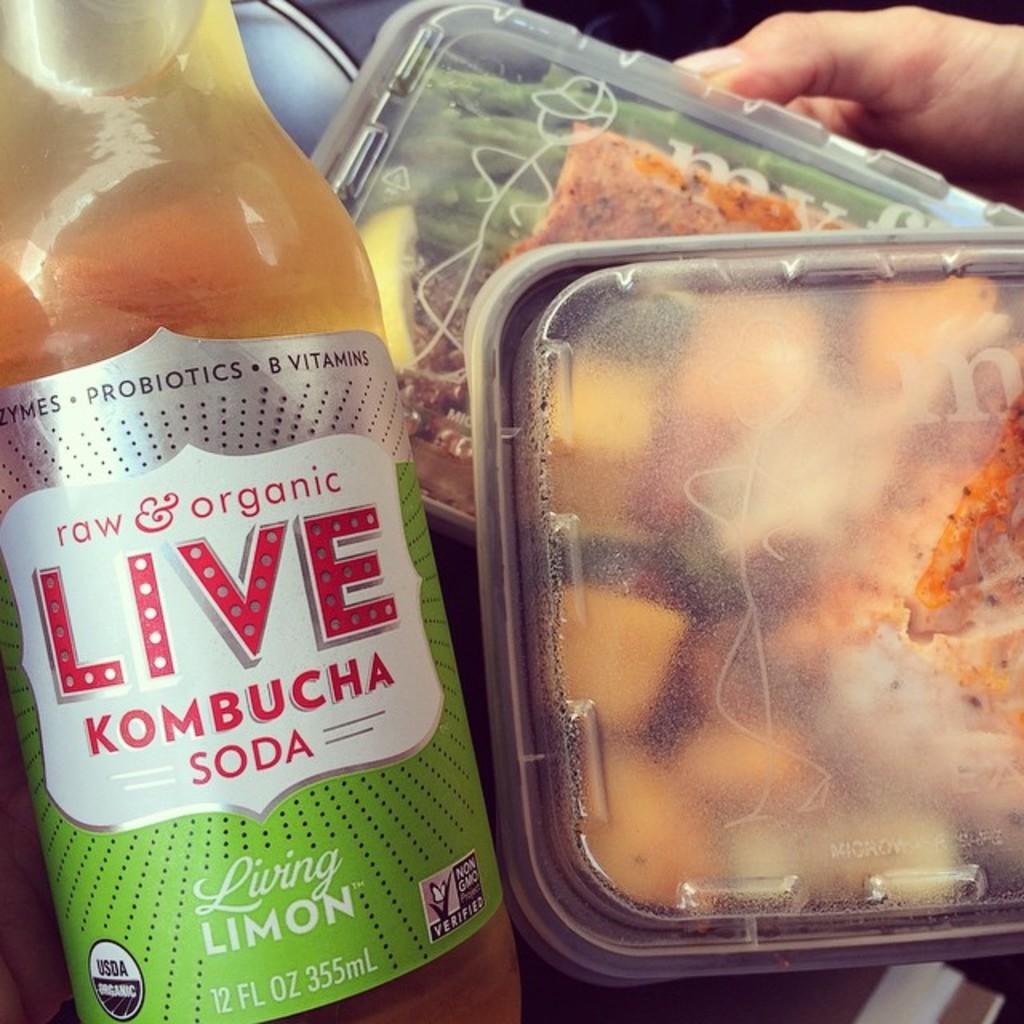What kind of soda is this?
Your answer should be very brief. Kombucha. How many fluid ounces are in the bottle?
Give a very brief answer. 12. 